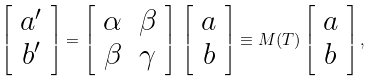Convert formula to latex. <formula><loc_0><loc_0><loc_500><loc_500>\left [ \begin{array} { c } a ^ { \prime } \\ b ^ { \prime } \end{array} \right ] = \left [ \begin{array} { c c } \alpha & \beta \\ \beta & \gamma \end{array} \right ] \, \left [ \begin{array} { c } a \\ b \end{array} \right ] \equiv M ( T ) \left [ \begin{array} { c } a \\ b \end{array} \right ] ,</formula> 